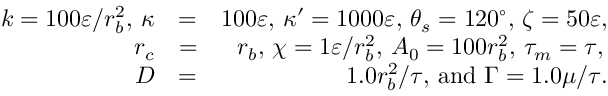Convert formula to latex. <formula><loc_0><loc_0><loc_500><loc_500>\begin{array} { r l r } { k = 1 0 0 \varepsilon / r _ { b } ^ { 2 } , \, \kappa } & { = } & { 1 0 0 \varepsilon , \, \kappa ^ { \prime } = 1 0 0 0 \varepsilon , \, \theta _ { s } = 1 2 0 ^ { \circ } , \, \zeta = 5 0 \varepsilon , } \\ { r _ { c } } & { = } & { r _ { b } , \, \chi = 1 \varepsilon / r _ { b } ^ { 2 } , \, A _ { 0 } = 1 0 0 r _ { b } ^ { 2 } , \, \tau _ { m } = \tau , \, } \\ { D } & { = } & { 1 . 0 r _ { b } ^ { 2 } / \tau , \, a n d \, \Gamma = 1 . 0 { \mu } / \tau . } \end{array}</formula> 